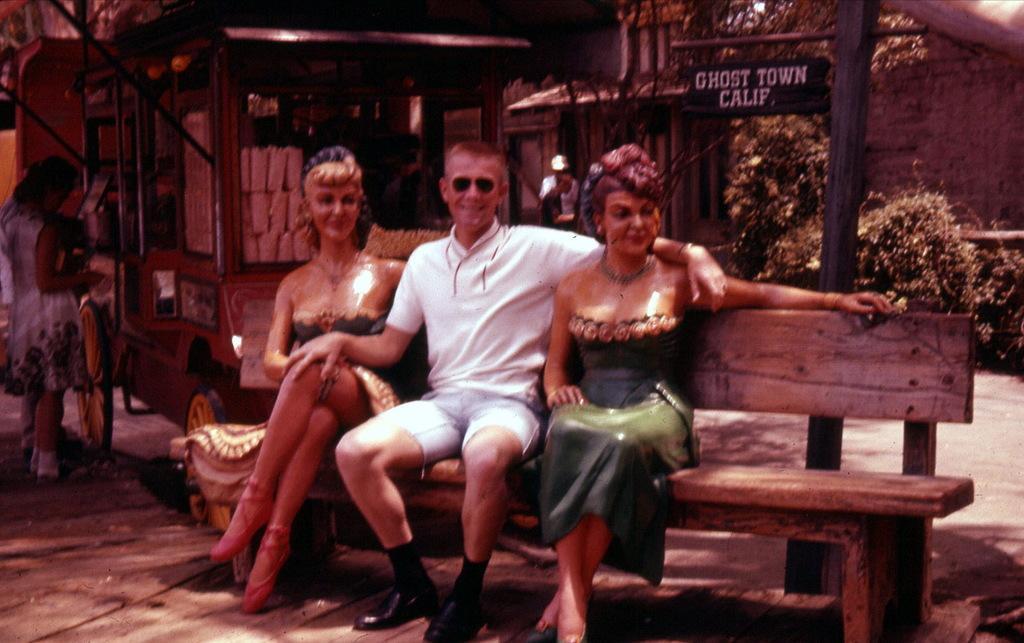How would you summarize this image in a sentence or two? This is a picture taken in the outdoor. The man in white t shirt was sitting on a bench in the middle to the man right and left side there are statues. Background of the man is a street pole, tree and a building 